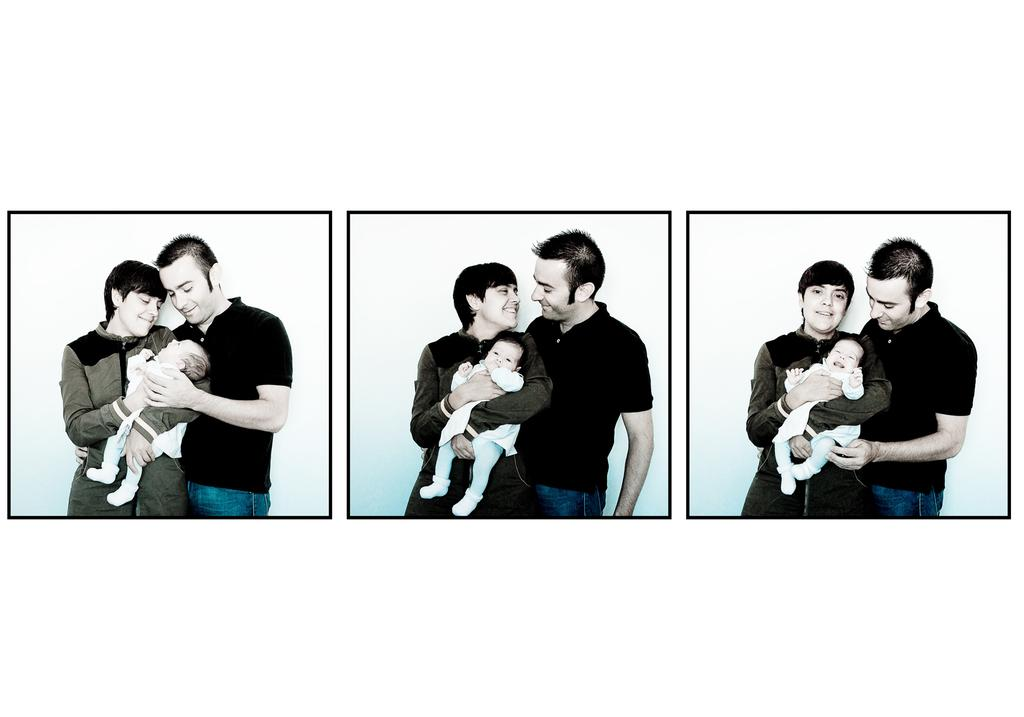What type of picture is in the image? The image contains a collage picture. How many people are in the collage picture? There are three people in the collage picture. What color is the background of the collage picture? The background of the collage picture is white. What type of meat is being cooked in the image? There is no meat or cooking activity present in the image; it contains a collage picture with three people and a white background. 